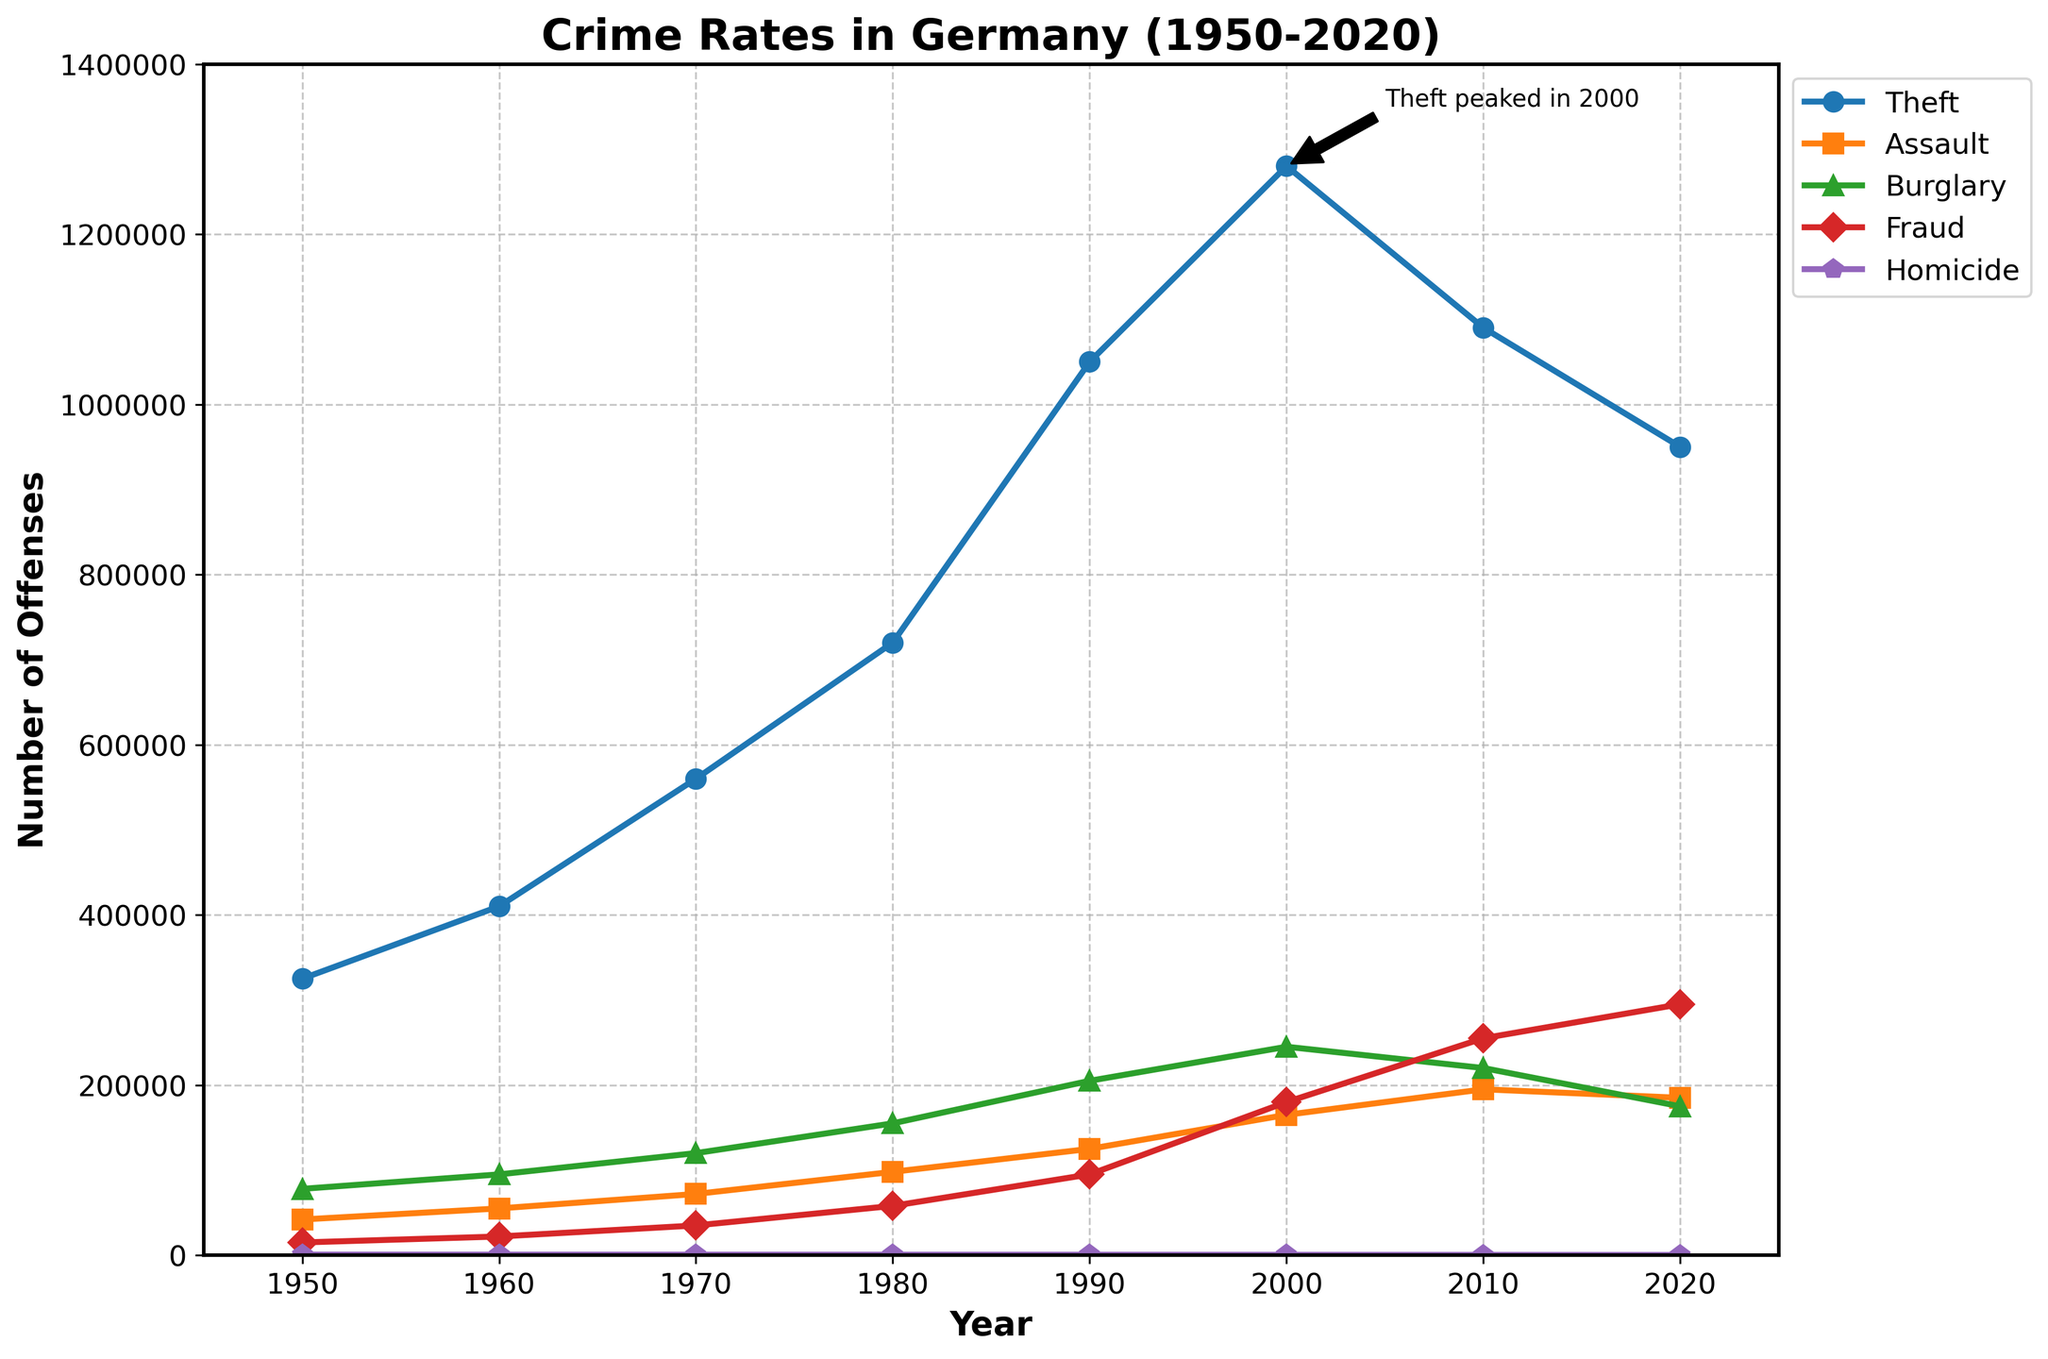What major offense peaked in 2000 according to the annotation in the figure? The annotation directly states that the offense "Theft" peaked in 2000 at about 1,280,000 offenses.
Answer: Theft Between which years did Burglary see the highest increase? By visually examining the slope of the lines in the figure, the steepest increase in Burglary appears between 1960 and 1980. The number of Burglary offenses went from 95,000 in 1960 to 155,000 in 1980, an increase of 60,000.
Answer: 1960 to 1980 How does the number of Homicide offenses in 2020 compare to that in 1950? Referring to the line representing Homicide, it is clear that it decreased from 720 in 1950 to 290 in 2020.
Answer: Decreased How many total theft offenses were reported from 1980 to 2020? Summing up the theft offenses for 1980 (720,000), 1990 (1,050,000), 2000 (1,280,000), 2010 (1,090,000), and 2020 (950,000): 720,000 + 1,050,000 + 1,280,000 + 1,090,000 + 950,000 = 5,090,000
Answer: 5,090,000 Which offense had the least variation in the number of offenses from 1950 to 2020? Visually, the line for Homicide is almost flat compared to the other offenses, indicating the least variation.
Answer: Homicide In which decade did Assault offenses see the largest increase? By looking at the slope of the Assault line, the largest increase appears to be between 1980 and 1990, where the offenses went from 98,000 to 125,000.
Answer: 1980 to 1990 What is the average number of Fraud offenses over the entire period? Adding up the Fraud offenses for the years 1950 (15,000), 1960 (22,000), 1970 (35,000), 1980 (58,000), 1990 (95,000), 2000 (180,000), 2010 (255,000), and 2020 (295,000): Total = 15,000 + 22,000 + 35,000 + 58,000 + 95,000 + 180,000 + 255,000 + 295,000 = 955,000. Dividing by the number of years (8) gives the average: 955,000 / 8 = 119,375.
Answer: 119,375 Which offense category had the second-highest number of offenses in 2010? Referring to the figure, Theft had the highest number of offenses with 1,090,000. The second highest in 2010 is Fraud with 255,000.
Answer: Fraud Compare the number of Fraud offenses in 2000 to the number of Burglary offenses in 2020. Which was higher and by how much? The number of Fraud offenses in 2000 is 180,000, and the number of Burglary offenses in 2020 is 175,000. Fraud in 2000 is higher by 5,000 offenses.
Answer: Fraud by 5,000 What trend can be observed about the overall crime rates from 2000 to 2020? Observing the general trend for all categories, most offense categories such as Theft, Burglary, and Homicide are decreasing, while Fraud is increasing.
Answer: Decrease in most categories except Fraud 